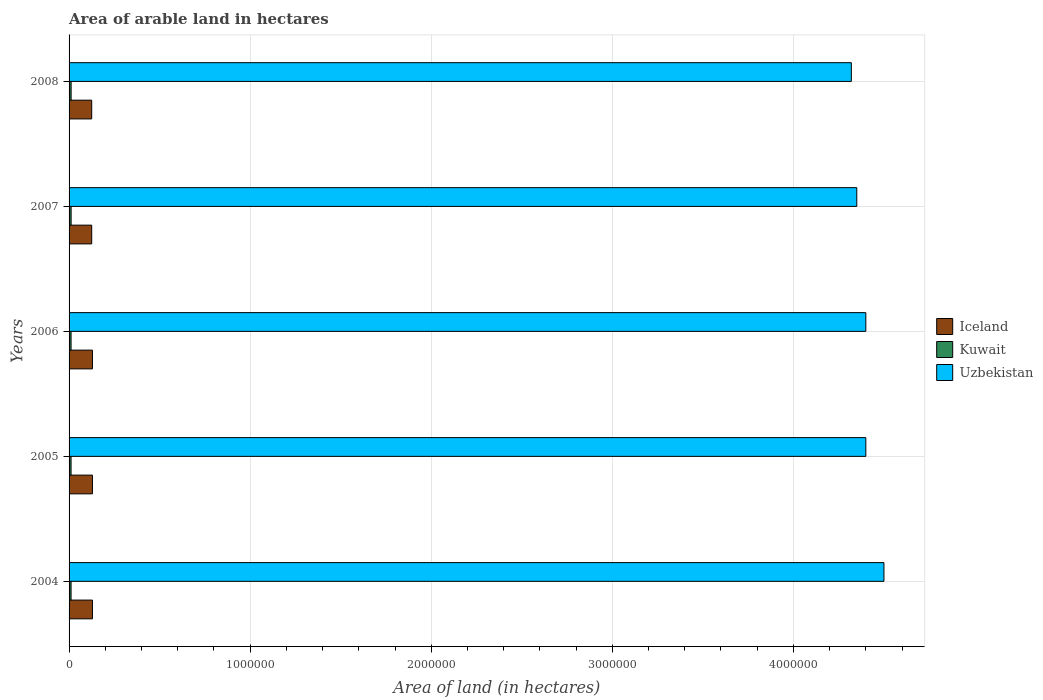How many different coloured bars are there?
Offer a terse response. 3. Are the number of bars per tick equal to the number of legend labels?
Provide a succinct answer. Yes. How many bars are there on the 2nd tick from the top?
Offer a very short reply. 3. What is the label of the 2nd group of bars from the top?
Make the answer very short. 2007. In how many cases, is the number of bars for a given year not equal to the number of legend labels?
Provide a succinct answer. 0. What is the total arable land in Uzbekistan in 2008?
Provide a short and direct response. 4.32e+06. Across all years, what is the maximum total arable land in Iceland?
Your answer should be compact. 1.29e+05. Across all years, what is the minimum total arable land in Uzbekistan?
Keep it short and to the point. 4.32e+06. What is the total total arable land in Iceland in the graph?
Offer a terse response. 6.37e+05. What is the difference between the total arable land in Kuwait in 2007 and that in 2008?
Ensure brevity in your answer.  0. What is the difference between the total arable land in Kuwait in 2006 and the total arable land in Iceland in 2008?
Give a very brief answer. -1.14e+05. What is the average total arable land in Kuwait per year?
Provide a short and direct response. 1.11e+04. In the year 2007, what is the difference between the total arable land in Uzbekistan and total arable land in Kuwait?
Provide a succinct answer. 4.34e+06. In how many years, is the total arable land in Iceland greater than 2000000 hectares?
Give a very brief answer. 0. Is the difference between the total arable land in Uzbekistan in 2005 and 2007 greater than the difference between the total arable land in Kuwait in 2005 and 2007?
Your response must be concise. Yes. What is the difference between the highest and the second highest total arable land in Iceland?
Provide a succinct answer. 0. What is the difference between the highest and the lowest total arable land in Iceland?
Offer a very short reply. 4000. In how many years, is the total arable land in Kuwait greater than the average total arable land in Kuwait taken over all years?
Ensure brevity in your answer.  2. What does the 2nd bar from the top in 2006 represents?
Keep it short and to the point. Kuwait. What does the 3rd bar from the bottom in 2008 represents?
Your answer should be compact. Uzbekistan. Is it the case that in every year, the sum of the total arable land in Kuwait and total arable land in Iceland is greater than the total arable land in Uzbekistan?
Give a very brief answer. No. Are all the bars in the graph horizontal?
Provide a short and direct response. Yes. Are the values on the major ticks of X-axis written in scientific E-notation?
Provide a short and direct response. No. Does the graph contain any zero values?
Ensure brevity in your answer.  No. Does the graph contain grids?
Your response must be concise. Yes. Where does the legend appear in the graph?
Ensure brevity in your answer.  Center right. What is the title of the graph?
Your answer should be compact. Area of arable land in hectares. What is the label or title of the X-axis?
Provide a succinct answer. Area of land (in hectares). What is the Area of land (in hectares) of Iceland in 2004?
Make the answer very short. 1.29e+05. What is the Area of land (in hectares) of Kuwait in 2004?
Your answer should be compact. 1.10e+04. What is the Area of land (in hectares) of Uzbekistan in 2004?
Give a very brief answer. 4.50e+06. What is the Area of land (in hectares) in Iceland in 2005?
Ensure brevity in your answer.  1.29e+05. What is the Area of land (in hectares) in Kuwait in 2005?
Your answer should be compact. 1.10e+04. What is the Area of land (in hectares) of Uzbekistan in 2005?
Your answer should be very brief. 4.40e+06. What is the Area of land (in hectares) in Iceland in 2006?
Offer a terse response. 1.29e+05. What is the Area of land (in hectares) in Kuwait in 2006?
Offer a very short reply. 1.10e+04. What is the Area of land (in hectares) of Uzbekistan in 2006?
Provide a short and direct response. 4.40e+06. What is the Area of land (in hectares) in Iceland in 2007?
Offer a very short reply. 1.25e+05. What is the Area of land (in hectares) in Kuwait in 2007?
Provide a succinct answer. 1.13e+04. What is the Area of land (in hectares) of Uzbekistan in 2007?
Give a very brief answer. 4.35e+06. What is the Area of land (in hectares) of Iceland in 2008?
Offer a terse response. 1.25e+05. What is the Area of land (in hectares) in Kuwait in 2008?
Your response must be concise. 1.13e+04. What is the Area of land (in hectares) in Uzbekistan in 2008?
Offer a terse response. 4.32e+06. Across all years, what is the maximum Area of land (in hectares) in Iceland?
Provide a short and direct response. 1.29e+05. Across all years, what is the maximum Area of land (in hectares) of Kuwait?
Your answer should be very brief. 1.13e+04. Across all years, what is the maximum Area of land (in hectares) in Uzbekistan?
Your answer should be very brief. 4.50e+06. Across all years, what is the minimum Area of land (in hectares) of Iceland?
Ensure brevity in your answer.  1.25e+05. Across all years, what is the minimum Area of land (in hectares) of Kuwait?
Offer a very short reply. 1.10e+04. Across all years, what is the minimum Area of land (in hectares) of Uzbekistan?
Provide a succinct answer. 4.32e+06. What is the total Area of land (in hectares) in Iceland in the graph?
Offer a terse response. 6.37e+05. What is the total Area of land (in hectares) in Kuwait in the graph?
Ensure brevity in your answer.  5.56e+04. What is the total Area of land (in hectares) in Uzbekistan in the graph?
Provide a succinct answer. 2.20e+07. What is the difference between the Area of land (in hectares) of Iceland in 2004 and that in 2005?
Provide a short and direct response. 0. What is the difference between the Area of land (in hectares) in Uzbekistan in 2004 and that in 2005?
Your answer should be compact. 1.00e+05. What is the difference between the Area of land (in hectares) in Kuwait in 2004 and that in 2006?
Keep it short and to the point. 0. What is the difference between the Area of land (in hectares) of Uzbekistan in 2004 and that in 2006?
Your response must be concise. 1.00e+05. What is the difference between the Area of land (in hectares) of Iceland in 2004 and that in 2007?
Your response must be concise. 4000. What is the difference between the Area of land (in hectares) in Kuwait in 2004 and that in 2007?
Your response must be concise. -300. What is the difference between the Area of land (in hectares) in Uzbekistan in 2004 and that in 2007?
Ensure brevity in your answer.  1.50e+05. What is the difference between the Area of land (in hectares) in Iceland in 2004 and that in 2008?
Your answer should be compact. 4000. What is the difference between the Area of land (in hectares) in Kuwait in 2004 and that in 2008?
Offer a very short reply. -300. What is the difference between the Area of land (in hectares) in Uzbekistan in 2004 and that in 2008?
Your response must be concise. 1.80e+05. What is the difference between the Area of land (in hectares) in Iceland in 2005 and that in 2006?
Make the answer very short. 0. What is the difference between the Area of land (in hectares) in Iceland in 2005 and that in 2007?
Your answer should be compact. 4000. What is the difference between the Area of land (in hectares) of Kuwait in 2005 and that in 2007?
Keep it short and to the point. -300. What is the difference between the Area of land (in hectares) in Uzbekistan in 2005 and that in 2007?
Keep it short and to the point. 5.00e+04. What is the difference between the Area of land (in hectares) in Iceland in 2005 and that in 2008?
Your answer should be very brief. 4000. What is the difference between the Area of land (in hectares) in Kuwait in 2005 and that in 2008?
Provide a short and direct response. -300. What is the difference between the Area of land (in hectares) in Uzbekistan in 2005 and that in 2008?
Your response must be concise. 8.00e+04. What is the difference between the Area of land (in hectares) in Iceland in 2006 and that in 2007?
Your answer should be compact. 4000. What is the difference between the Area of land (in hectares) in Kuwait in 2006 and that in 2007?
Provide a short and direct response. -300. What is the difference between the Area of land (in hectares) of Uzbekistan in 2006 and that in 2007?
Provide a short and direct response. 5.00e+04. What is the difference between the Area of land (in hectares) in Iceland in 2006 and that in 2008?
Give a very brief answer. 4000. What is the difference between the Area of land (in hectares) in Kuwait in 2006 and that in 2008?
Your answer should be very brief. -300. What is the difference between the Area of land (in hectares) in Uzbekistan in 2007 and that in 2008?
Make the answer very short. 3.00e+04. What is the difference between the Area of land (in hectares) of Iceland in 2004 and the Area of land (in hectares) of Kuwait in 2005?
Give a very brief answer. 1.18e+05. What is the difference between the Area of land (in hectares) of Iceland in 2004 and the Area of land (in hectares) of Uzbekistan in 2005?
Give a very brief answer. -4.27e+06. What is the difference between the Area of land (in hectares) in Kuwait in 2004 and the Area of land (in hectares) in Uzbekistan in 2005?
Make the answer very short. -4.39e+06. What is the difference between the Area of land (in hectares) of Iceland in 2004 and the Area of land (in hectares) of Kuwait in 2006?
Keep it short and to the point. 1.18e+05. What is the difference between the Area of land (in hectares) in Iceland in 2004 and the Area of land (in hectares) in Uzbekistan in 2006?
Keep it short and to the point. -4.27e+06. What is the difference between the Area of land (in hectares) in Kuwait in 2004 and the Area of land (in hectares) in Uzbekistan in 2006?
Provide a short and direct response. -4.39e+06. What is the difference between the Area of land (in hectares) of Iceland in 2004 and the Area of land (in hectares) of Kuwait in 2007?
Your answer should be compact. 1.18e+05. What is the difference between the Area of land (in hectares) in Iceland in 2004 and the Area of land (in hectares) in Uzbekistan in 2007?
Your answer should be compact. -4.22e+06. What is the difference between the Area of land (in hectares) in Kuwait in 2004 and the Area of land (in hectares) in Uzbekistan in 2007?
Give a very brief answer. -4.34e+06. What is the difference between the Area of land (in hectares) of Iceland in 2004 and the Area of land (in hectares) of Kuwait in 2008?
Offer a terse response. 1.18e+05. What is the difference between the Area of land (in hectares) of Iceland in 2004 and the Area of land (in hectares) of Uzbekistan in 2008?
Your answer should be compact. -4.19e+06. What is the difference between the Area of land (in hectares) of Kuwait in 2004 and the Area of land (in hectares) of Uzbekistan in 2008?
Ensure brevity in your answer.  -4.31e+06. What is the difference between the Area of land (in hectares) of Iceland in 2005 and the Area of land (in hectares) of Kuwait in 2006?
Ensure brevity in your answer.  1.18e+05. What is the difference between the Area of land (in hectares) of Iceland in 2005 and the Area of land (in hectares) of Uzbekistan in 2006?
Ensure brevity in your answer.  -4.27e+06. What is the difference between the Area of land (in hectares) of Kuwait in 2005 and the Area of land (in hectares) of Uzbekistan in 2006?
Ensure brevity in your answer.  -4.39e+06. What is the difference between the Area of land (in hectares) of Iceland in 2005 and the Area of land (in hectares) of Kuwait in 2007?
Your answer should be compact. 1.18e+05. What is the difference between the Area of land (in hectares) of Iceland in 2005 and the Area of land (in hectares) of Uzbekistan in 2007?
Your answer should be very brief. -4.22e+06. What is the difference between the Area of land (in hectares) of Kuwait in 2005 and the Area of land (in hectares) of Uzbekistan in 2007?
Your answer should be compact. -4.34e+06. What is the difference between the Area of land (in hectares) of Iceland in 2005 and the Area of land (in hectares) of Kuwait in 2008?
Your answer should be very brief. 1.18e+05. What is the difference between the Area of land (in hectares) of Iceland in 2005 and the Area of land (in hectares) of Uzbekistan in 2008?
Your answer should be very brief. -4.19e+06. What is the difference between the Area of land (in hectares) of Kuwait in 2005 and the Area of land (in hectares) of Uzbekistan in 2008?
Offer a very short reply. -4.31e+06. What is the difference between the Area of land (in hectares) in Iceland in 2006 and the Area of land (in hectares) in Kuwait in 2007?
Offer a very short reply. 1.18e+05. What is the difference between the Area of land (in hectares) in Iceland in 2006 and the Area of land (in hectares) in Uzbekistan in 2007?
Offer a terse response. -4.22e+06. What is the difference between the Area of land (in hectares) of Kuwait in 2006 and the Area of land (in hectares) of Uzbekistan in 2007?
Offer a terse response. -4.34e+06. What is the difference between the Area of land (in hectares) in Iceland in 2006 and the Area of land (in hectares) in Kuwait in 2008?
Your answer should be very brief. 1.18e+05. What is the difference between the Area of land (in hectares) in Iceland in 2006 and the Area of land (in hectares) in Uzbekistan in 2008?
Make the answer very short. -4.19e+06. What is the difference between the Area of land (in hectares) of Kuwait in 2006 and the Area of land (in hectares) of Uzbekistan in 2008?
Your response must be concise. -4.31e+06. What is the difference between the Area of land (in hectares) of Iceland in 2007 and the Area of land (in hectares) of Kuwait in 2008?
Ensure brevity in your answer.  1.14e+05. What is the difference between the Area of land (in hectares) of Iceland in 2007 and the Area of land (in hectares) of Uzbekistan in 2008?
Your answer should be very brief. -4.20e+06. What is the difference between the Area of land (in hectares) of Kuwait in 2007 and the Area of land (in hectares) of Uzbekistan in 2008?
Provide a succinct answer. -4.31e+06. What is the average Area of land (in hectares) in Iceland per year?
Make the answer very short. 1.27e+05. What is the average Area of land (in hectares) in Kuwait per year?
Provide a short and direct response. 1.11e+04. What is the average Area of land (in hectares) of Uzbekistan per year?
Provide a short and direct response. 4.39e+06. In the year 2004, what is the difference between the Area of land (in hectares) of Iceland and Area of land (in hectares) of Kuwait?
Your answer should be very brief. 1.18e+05. In the year 2004, what is the difference between the Area of land (in hectares) of Iceland and Area of land (in hectares) of Uzbekistan?
Offer a terse response. -4.37e+06. In the year 2004, what is the difference between the Area of land (in hectares) in Kuwait and Area of land (in hectares) in Uzbekistan?
Give a very brief answer. -4.49e+06. In the year 2005, what is the difference between the Area of land (in hectares) in Iceland and Area of land (in hectares) in Kuwait?
Provide a succinct answer. 1.18e+05. In the year 2005, what is the difference between the Area of land (in hectares) in Iceland and Area of land (in hectares) in Uzbekistan?
Keep it short and to the point. -4.27e+06. In the year 2005, what is the difference between the Area of land (in hectares) of Kuwait and Area of land (in hectares) of Uzbekistan?
Your answer should be compact. -4.39e+06. In the year 2006, what is the difference between the Area of land (in hectares) of Iceland and Area of land (in hectares) of Kuwait?
Your answer should be compact. 1.18e+05. In the year 2006, what is the difference between the Area of land (in hectares) of Iceland and Area of land (in hectares) of Uzbekistan?
Make the answer very short. -4.27e+06. In the year 2006, what is the difference between the Area of land (in hectares) in Kuwait and Area of land (in hectares) in Uzbekistan?
Provide a succinct answer. -4.39e+06. In the year 2007, what is the difference between the Area of land (in hectares) of Iceland and Area of land (in hectares) of Kuwait?
Provide a succinct answer. 1.14e+05. In the year 2007, what is the difference between the Area of land (in hectares) of Iceland and Area of land (in hectares) of Uzbekistan?
Your answer should be very brief. -4.22e+06. In the year 2007, what is the difference between the Area of land (in hectares) in Kuwait and Area of land (in hectares) in Uzbekistan?
Give a very brief answer. -4.34e+06. In the year 2008, what is the difference between the Area of land (in hectares) in Iceland and Area of land (in hectares) in Kuwait?
Provide a short and direct response. 1.14e+05. In the year 2008, what is the difference between the Area of land (in hectares) in Iceland and Area of land (in hectares) in Uzbekistan?
Keep it short and to the point. -4.20e+06. In the year 2008, what is the difference between the Area of land (in hectares) of Kuwait and Area of land (in hectares) of Uzbekistan?
Offer a terse response. -4.31e+06. What is the ratio of the Area of land (in hectares) of Kuwait in 2004 to that in 2005?
Keep it short and to the point. 1. What is the ratio of the Area of land (in hectares) in Uzbekistan in 2004 to that in 2005?
Ensure brevity in your answer.  1.02. What is the ratio of the Area of land (in hectares) of Kuwait in 2004 to that in 2006?
Offer a terse response. 1. What is the ratio of the Area of land (in hectares) in Uzbekistan in 2004 to that in 2006?
Your response must be concise. 1.02. What is the ratio of the Area of land (in hectares) in Iceland in 2004 to that in 2007?
Keep it short and to the point. 1.03. What is the ratio of the Area of land (in hectares) in Kuwait in 2004 to that in 2007?
Your answer should be compact. 0.97. What is the ratio of the Area of land (in hectares) of Uzbekistan in 2004 to that in 2007?
Your response must be concise. 1.03. What is the ratio of the Area of land (in hectares) in Iceland in 2004 to that in 2008?
Your answer should be very brief. 1.03. What is the ratio of the Area of land (in hectares) of Kuwait in 2004 to that in 2008?
Your answer should be very brief. 0.97. What is the ratio of the Area of land (in hectares) of Uzbekistan in 2004 to that in 2008?
Make the answer very short. 1.04. What is the ratio of the Area of land (in hectares) of Kuwait in 2005 to that in 2006?
Ensure brevity in your answer.  1. What is the ratio of the Area of land (in hectares) of Uzbekistan in 2005 to that in 2006?
Your answer should be very brief. 1. What is the ratio of the Area of land (in hectares) in Iceland in 2005 to that in 2007?
Provide a short and direct response. 1.03. What is the ratio of the Area of land (in hectares) of Kuwait in 2005 to that in 2007?
Ensure brevity in your answer.  0.97. What is the ratio of the Area of land (in hectares) of Uzbekistan in 2005 to that in 2007?
Provide a short and direct response. 1.01. What is the ratio of the Area of land (in hectares) in Iceland in 2005 to that in 2008?
Your response must be concise. 1.03. What is the ratio of the Area of land (in hectares) in Kuwait in 2005 to that in 2008?
Your answer should be very brief. 0.97. What is the ratio of the Area of land (in hectares) in Uzbekistan in 2005 to that in 2008?
Your response must be concise. 1.02. What is the ratio of the Area of land (in hectares) in Iceland in 2006 to that in 2007?
Your answer should be compact. 1.03. What is the ratio of the Area of land (in hectares) of Kuwait in 2006 to that in 2007?
Provide a succinct answer. 0.97. What is the ratio of the Area of land (in hectares) in Uzbekistan in 2006 to that in 2007?
Your answer should be very brief. 1.01. What is the ratio of the Area of land (in hectares) in Iceland in 2006 to that in 2008?
Provide a succinct answer. 1.03. What is the ratio of the Area of land (in hectares) in Kuwait in 2006 to that in 2008?
Keep it short and to the point. 0.97. What is the ratio of the Area of land (in hectares) in Uzbekistan in 2006 to that in 2008?
Provide a succinct answer. 1.02. What is the ratio of the Area of land (in hectares) in Kuwait in 2007 to that in 2008?
Your answer should be very brief. 1. What is the difference between the highest and the second highest Area of land (in hectares) in Iceland?
Provide a short and direct response. 0. What is the difference between the highest and the second highest Area of land (in hectares) of Kuwait?
Provide a short and direct response. 0. What is the difference between the highest and the second highest Area of land (in hectares) in Uzbekistan?
Your answer should be compact. 1.00e+05. What is the difference between the highest and the lowest Area of land (in hectares) of Iceland?
Your answer should be compact. 4000. What is the difference between the highest and the lowest Area of land (in hectares) of Kuwait?
Keep it short and to the point. 300. What is the difference between the highest and the lowest Area of land (in hectares) of Uzbekistan?
Ensure brevity in your answer.  1.80e+05. 